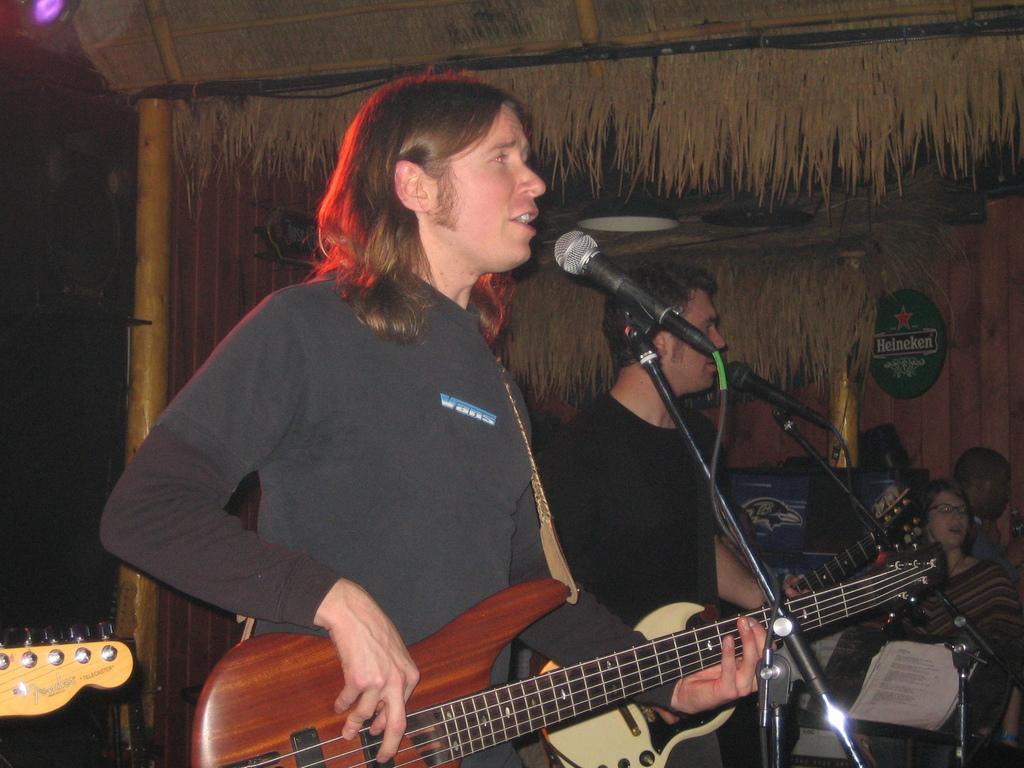In one or two sentences, can you explain what this image depicts? A man is playing guitar and singing. In front of him there is a mic and mic stand. Behind him another person is holding guitar and singing. In the back there is a hit with bamboo. And there are many persons. There are papers. 